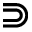Convert formula to latex. <formula><loc_0><loc_0><loc_500><loc_500>\S u p s e t</formula> 